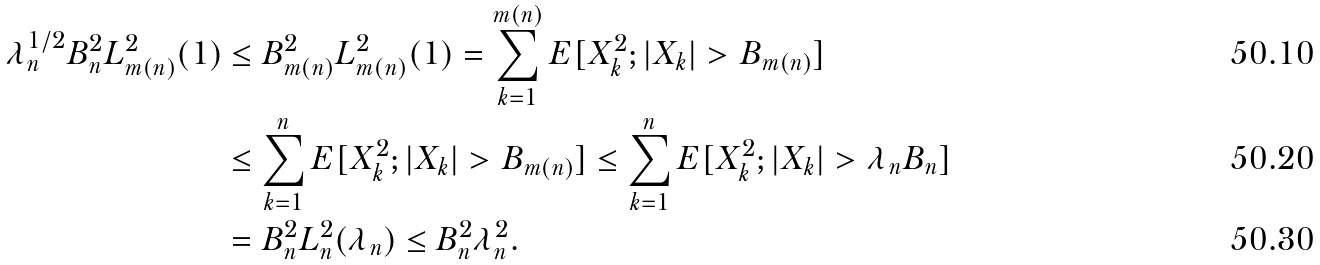<formula> <loc_0><loc_0><loc_500><loc_500>\lambda _ { n } ^ { 1 / 2 } B _ { n } ^ { 2 } L _ { m ( n ) } ^ { 2 } ( 1 ) & \leq B _ { m ( n ) } ^ { 2 } L _ { m ( n ) } ^ { 2 } ( 1 ) = \sum _ { k = 1 } ^ { m ( n ) } E [ X _ { k } ^ { 2 } ; | X _ { k } | > B _ { m ( n ) } ] \\ & \leq \sum _ { k = 1 } ^ { n } E [ X _ { k } ^ { 2 } ; | X _ { k } | > B _ { m ( n ) } ] \leq \sum _ { k = 1 } ^ { n } E [ X _ { k } ^ { 2 } ; | X _ { k } | > \lambda _ { n } B _ { n } ] \\ & = B _ { n } ^ { 2 } L _ { n } ^ { 2 } ( \lambda _ { n } ) \leq B _ { n } ^ { 2 } \lambda _ { n } ^ { 2 } .</formula> 